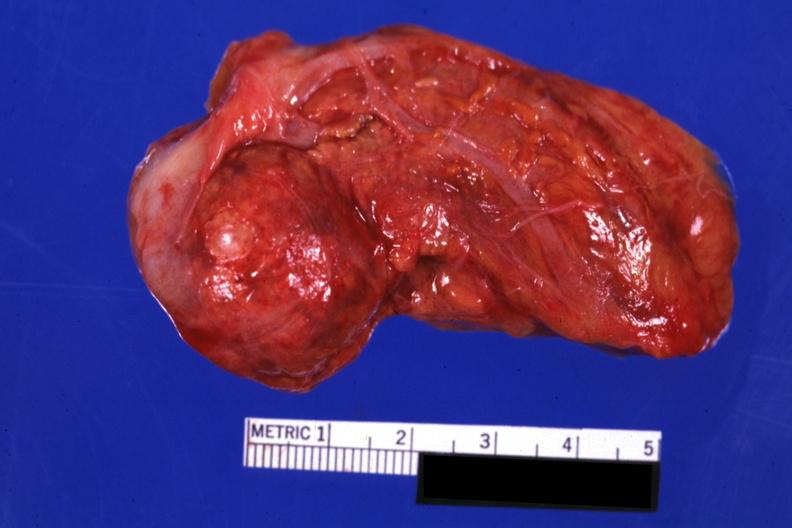what is present?
Answer the question using a single word or phrase. Adrenal 